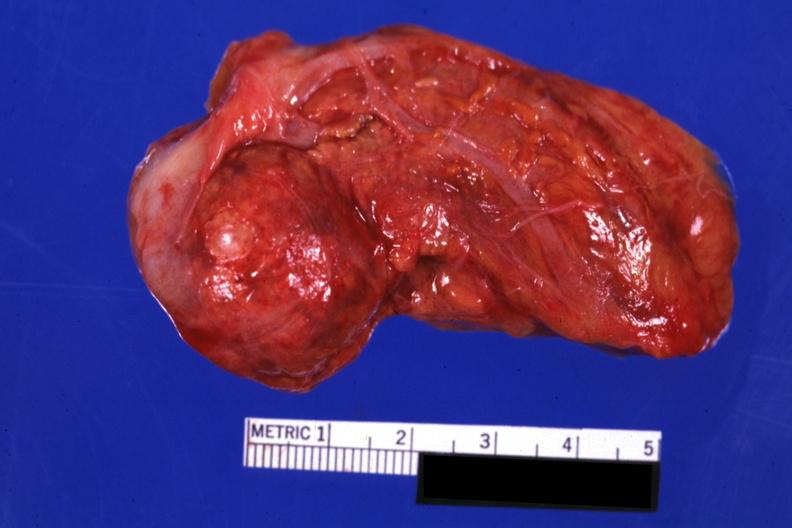what is present?
Answer the question using a single word or phrase. Adrenal 